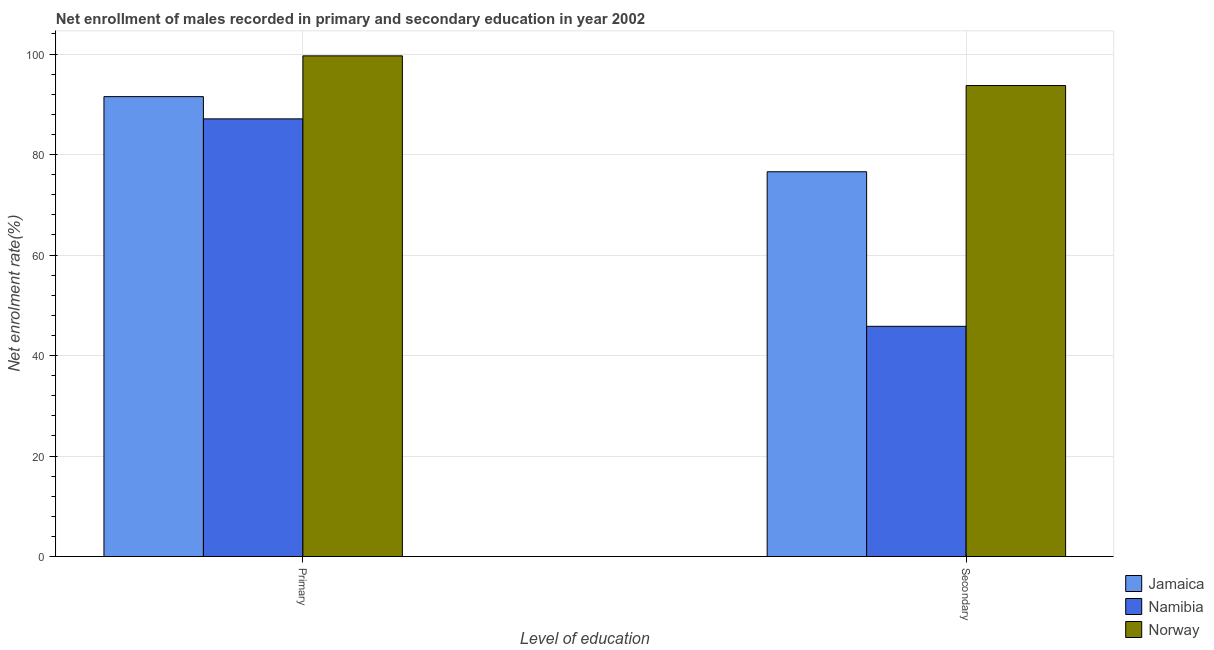How many different coloured bars are there?
Offer a terse response. 3. How many groups of bars are there?
Provide a short and direct response. 2. Are the number of bars per tick equal to the number of legend labels?
Your answer should be compact. Yes. Are the number of bars on each tick of the X-axis equal?
Provide a succinct answer. Yes. What is the label of the 2nd group of bars from the left?
Offer a terse response. Secondary. What is the enrollment rate in primary education in Namibia?
Offer a very short reply. 87.09. Across all countries, what is the maximum enrollment rate in primary education?
Offer a terse response. 99.63. Across all countries, what is the minimum enrollment rate in primary education?
Provide a succinct answer. 87.09. In which country was the enrollment rate in secondary education minimum?
Keep it short and to the point. Namibia. What is the total enrollment rate in secondary education in the graph?
Provide a succinct answer. 216.11. What is the difference between the enrollment rate in secondary education in Namibia and that in Jamaica?
Provide a short and direct response. -30.76. What is the difference between the enrollment rate in secondary education in Namibia and the enrollment rate in primary education in Jamaica?
Offer a terse response. -45.71. What is the average enrollment rate in secondary education per country?
Keep it short and to the point. 72.04. What is the difference between the enrollment rate in primary education and enrollment rate in secondary education in Norway?
Your response must be concise. 5.91. In how many countries, is the enrollment rate in primary education greater than 44 %?
Your response must be concise. 3. What is the ratio of the enrollment rate in primary education in Jamaica to that in Norway?
Provide a short and direct response. 0.92. Is the enrollment rate in secondary education in Namibia less than that in Jamaica?
Your response must be concise. Yes. In how many countries, is the enrollment rate in secondary education greater than the average enrollment rate in secondary education taken over all countries?
Give a very brief answer. 2. What does the 1st bar from the left in Primary represents?
Your response must be concise. Jamaica. What does the 3rd bar from the right in Secondary represents?
Offer a very short reply. Jamaica. How many bars are there?
Keep it short and to the point. 6. Are all the bars in the graph horizontal?
Provide a succinct answer. No. Are the values on the major ticks of Y-axis written in scientific E-notation?
Your answer should be very brief. No. Where does the legend appear in the graph?
Ensure brevity in your answer.  Bottom right. What is the title of the graph?
Offer a terse response. Net enrollment of males recorded in primary and secondary education in year 2002. What is the label or title of the X-axis?
Your answer should be compact. Level of education. What is the label or title of the Y-axis?
Your answer should be very brief. Net enrolment rate(%). What is the Net enrolment rate(%) of Jamaica in Primary?
Provide a short and direct response. 91.52. What is the Net enrolment rate(%) in Namibia in Primary?
Offer a very short reply. 87.09. What is the Net enrolment rate(%) of Norway in Primary?
Your answer should be compact. 99.63. What is the Net enrolment rate(%) in Jamaica in Secondary?
Offer a terse response. 76.57. What is the Net enrolment rate(%) of Namibia in Secondary?
Give a very brief answer. 45.81. What is the Net enrolment rate(%) of Norway in Secondary?
Provide a succinct answer. 93.72. Across all Level of education, what is the maximum Net enrolment rate(%) of Jamaica?
Your answer should be very brief. 91.52. Across all Level of education, what is the maximum Net enrolment rate(%) of Namibia?
Offer a terse response. 87.09. Across all Level of education, what is the maximum Net enrolment rate(%) of Norway?
Keep it short and to the point. 99.63. Across all Level of education, what is the minimum Net enrolment rate(%) in Jamaica?
Give a very brief answer. 76.57. Across all Level of education, what is the minimum Net enrolment rate(%) of Namibia?
Give a very brief answer. 45.81. Across all Level of education, what is the minimum Net enrolment rate(%) in Norway?
Give a very brief answer. 93.72. What is the total Net enrolment rate(%) in Jamaica in the graph?
Offer a terse response. 168.09. What is the total Net enrolment rate(%) in Namibia in the graph?
Your answer should be compact. 132.9. What is the total Net enrolment rate(%) of Norway in the graph?
Offer a very short reply. 193.36. What is the difference between the Net enrolment rate(%) in Jamaica in Primary and that in Secondary?
Offer a terse response. 14.95. What is the difference between the Net enrolment rate(%) of Namibia in Primary and that in Secondary?
Keep it short and to the point. 41.28. What is the difference between the Net enrolment rate(%) in Norway in Primary and that in Secondary?
Your response must be concise. 5.91. What is the difference between the Net enrolment rate(%) in Jamaica in Primary and the Net enrolment rate(%) in Namibia in Secondary?
Make the answer very short. 45.71. What is the difference between the Net enrolment rate(%) of Jamaica in Primary and the Net enrolment rate(%) of Norway in Secondary?
Ensure brevity in your answer.  -2.21. What is the difference between the Net enrolment rate(%) in Namibia in Primary and the Net enrolment rate(%) in Norway in Secondary?
Give a very brief answer. -6.63. What is the average Net enrolment rate(%) in Jamaica per Level of education?
Offer a very short reply. 84.04. What is the average Net enrolment rate(%) of Namibia per Level of education?
Offer a very short reply. 66.45. What is the average Net enrolment rate(%) in Norway per Level of education?
Your response must be concise. 96.68. What is the difference between the Net enrolment rate(%) of Jamaica and Net enrolment rate(%) of Namibia in Primary?
Provide a succinct answer. 4.43. What is the difference between the Net enrolment rate(%) in Jamaica and Net enrolment rate(%) in Norway in Primary?
Give a very brief answer. -8.11. What is the difference between the Net enrolment rate(%) in Namibia and Net enrolment rate(%) in Norway in Primary?
Provide a short and direct response. -12.54. What is the difference between the Net enrolment rate(%) in Jamaica and Net enrolment rate(%) in Namibia in Secondary?
Provide a succinct answer. 30.76. What is the difference between the Net enrolment rate(%) of Jamaica and Net enrolment rate(%) of Norway in Secondary?
Make the answer very short. -17.15. What is the difference between the Net enrolment rate(%) of Namibia and Net enrolment rate(%) of Norway in Secondary?
Offer a terse response. -47.91. What is the ratio of the Net enrolment rate(%) of Jamaica in Primary to that in Secondary?
Provide a short and direct response. 1.2. What is the ratio of the Net enrolment rate(%) of Namibia in Primary to that in Secondary?
Keep it short and to the point. 1.9. What is the ratio of the Net enrolment rate(%) of Norway in Primary to that in Secondary?
Provide a short and direct response. 1.06. What is the difference between the highest and the second highest Net enrolment rate(%) of Jamaica?
Offer a terse response. 14.95. What is the difference between the highest and the second highest Net enrolment rate(%) in Namibia?
Provide a short and direct response. 41.28. What is the difference between the highest and the second highest Net enrolment rate(%) in Norway?
Give a very brief answer. 5.91. What is the difference between the highest and the lowest Net enrolment rate(%) of Jamaica?
Your answer should be very brief. 14.95. What is the difference between the highest and the lowest Net enrolment rate(%) of Namibia?
Offer a terse response. 41.28. What is the difference between the highest and the lowest Net enrolment rate(%) in Norway?
Give a very brief answer. 5.91. 